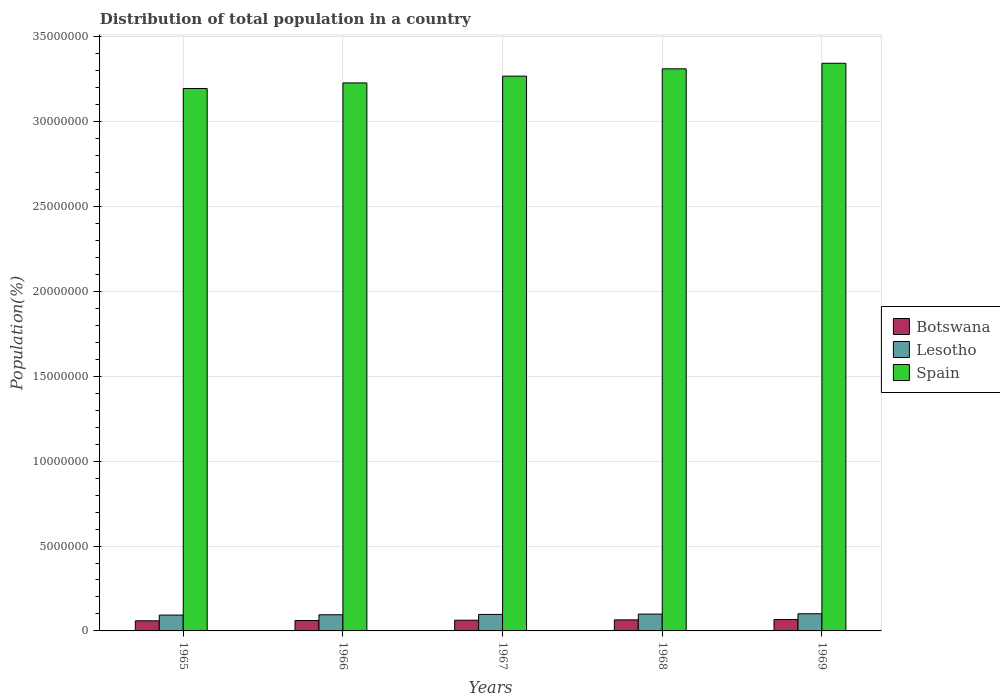Are the number of bars per tick equal to the number of legend labels?
Provide a succinct answer. Yes. How many bars are there on the 5th tick from the right?
Give a very brief answer. 3. What is the label of the 5th group of bars from the left?
Provide a succinct answer. 1969. In how many cases, is the number of bars for a given year not equal to the number of legend labels?
Ensure brevity in your answer.  0. What is the population of in Spain in 1967?
Provide a short and direct response. 3.27e+07. Across all years, what is the maximum population of in Lesotho?
Provide a succinct answer. 1.01e+06. Across all years, what is the minimum population of in Botswana?
Give a very brief answer. 5.96e+05. In which year was the population of in Lesotho maximum?
Provide a short and direct response. 1969. In which year was the population of in Spain minimum?
Provide a succinct answer. 1965. What is the total population of in Botswana in the graph?
Give a very brief answer. 3.16e+06. What is the difference between the population of in Botswana in 1967 and that in 1969?
Keep it short and to the point. -4.00e+04. What is the difference between the population of in Lesotho in 1965 and the population of in Botswana in 1968?
Provide a short and direct response. 2.83e+05. What is the average population of in Lesotho per year?
Offer a very short reply. 9.72e+05. In the year 1968, what is the difference between the population of in Spain and population of in Botswana?
Ensure brevity in your answer.  3.25e+07. What is the ratio of the population of in Lesotho in 1965 to that in 1969?
Your response must be concise. 0.92. What is the difference between the highest and the second highest population of in Botswana?
Offer a very short reply. 2.06e+04. What is the difference between the highest and the lowest population of in Spain?
Give a very brief answer. 1.49e+06. In how many years, is the population of in Botswana greater than the average population of in Botswana taken over all years?
Your response must be concise. 2. What does the 2nd bar from the left in 1966 represents?
Your answer should be very brief. Lesotho. Is it the case that in every year, the sum of the population of in Spain and population of in Botswana is greater than the population of in Lesotho?
Offer a terse response. Yes. How many years are there in the graph?
Give a very brief answer. 5. What is the difference between two consecutive major ticks on the Y-axis?
Offer a terse response. 5.00e+06. Are the values on the major ticks of Y-axis written in scientific E-notation?
Make the answer very short. No. Does the graph contain any zero values?
Make the answer very short. No. Where does the legend appear in the graph?
Offer a very short reply. Center right. What is the title of the graph?
Make the answer very short. Distribution of total population in a country. What is the label or title of the X-axis?
Ensure brevity in your answer.  Years. What is the label or title of the Y-axis?
Keep it short and to the point. Population(%). What is the Population(%) in Botswana in 1965?
Your response must be concise. 5.96e+05. What is the Population(%) in Lesotho in 1965?
Your answer should be very brief. 9.33e+05. What is the Population(%) of Spain in 1965?
Ensure brevity in your answer.  3.20e+07. What is the Population(%) in Botswana in 1966?
Ensure brevity in your answer.  6.13e+05. What is the Population(%) of Lesotho in 1966?
Your answer should be very brief. 9.52e+05. What is the Population(%) of Spain in 1966?
Offer a terse response. 3.23e+07. What is the Population(%) in Botswana in 1967?
Ensure brevity in your answer.  6.31e+05. What is the Population(%) of Lesotho in 1967?
Provide a short and direct response. 9.71e+05. What is the Population(%) in Spain in 1967?
Make the answer very short. 3.27e+07. What is the Population(%) of Botswana in 1968?
Offer a very short reply. 6.51e+05. What is the Population(%) of Lesotho in 1968?
Offer a very short reply. 9.91e+05. What is the Population(%) in Spain in 1968?
Offer a very short reply. 3.31e+07. What is the Population(%) in Botswana in 1969?
Your response must be concise. 6.71e+05. What is the Population(%) in Lesotho in 1969?
Offer a very short reply. 1.01e+06. What is the Population(%) of Spain in 1969?
Your answer should be very brief. 3.34e+07. Across all years, what is the maximum Population(%) of Botswana?
Offer a terse response. 6.71e+05. Across all years, what is the maximum Population(%) in Lesotho?
Ensure brevity in your answer.  1.01e+06. Across all years, what is the maximum Population(%) in Spain?
Offer a very short reply. 3.34e+07. Across all years, what is the minimum Population(%) in Botswana?
Ensure brevity in your answer.  5.96e+05. Across all years, what is the minimum Population(%) of Lesotho?
Offer a very short reply. 9.33e+05. Across all years, what is the minimum Population(%) of Spain?
Ensure brevity in your answer.  3.20e+07. What is the total Population(%) of Botswana in the graph?
Give a very brief answer. 3.16e+06. What is the total Population(%) in Lesotho in the graph?
Ensure brevity in your answer.  4.86e+06. What is the total Population(%) of Spain in the graph?
Your answer should be very brief. 1.63e+08. What is the difference between the Population(%) of Botswana in 1965 and that in 1966?
Give a very brief answer. -1.72e+04. What is the difference between the Population(%) in Lesotho in 1965 and that in 1966?
Ensure brevity in your answer.  -1.85e+04. What is the difference between the Population(%) of Spain in 1965 and that in 1966?
Your response must be concise. -3.29e+05. What is the difference between the Population(%) of Botswana in 1965 and that in 1967?
Keep it short and to the point. -3.55e+04. What is the difference between the Population(%) in Lesotho in 1965 and that in 1967?
Give a very brief answer. -3.77e+04. What is the difference between the Population(%) of Spain in 1965 and that in 1967?
Make the answer very short. -7.29e+05. What is the difference between the Population(%) in Botswana in 1965 and that in 1968?
Provide a short and direct response. -5.50e+04. What is the difference between the Population(%) in Lesotho in 1965 and that in 1968?
Give a very brief answer. -5.76e+04. What is the difference between the Population(%) in Spain in 1965 and that in 1968?
Offer a terse response. -1.16e+06. What is the difference between the Population(%) in Botswana in 1965 and that in 1969?
Give a very brief answer. -7.56e+04. What is the difference between the Population(%) of Lesotho in 1965 and that in 1969?
Provide a short and direct response. -7.81e+04. What is the difference between the Population(%) of Spain in 1965 and that in 1969?
Offer a terse response. -1.49e+06. What is the difference between the Population(%) in Botswana in 1966 and that in 1967?
Make the answer very short. -1.83e+04. What is the difference between the Population(%) of Lesotho in 1966 and that in 1967?
Give a very brief answer. -1.92e+04. What is the difference between the Population(%) in Spain in 1966 and that in 1967?
Your answer should be compact. -4.00e+05. What is the difference between the Population(%) in Botswana in 1966 and that in 1968?
Your response must be concise. -3.78e+04. What is the difference between the Population(%) of Lesotho in 1966 and that in 1968?
Ensure brevity in your answer.  -3.91e+04. What is the difference between the Population(%) of Spain in 1966 and that in 1968?
Provide a short and direct response. -8.30e+05. What is the difference between the Population(%) of Botswana in 1966 and that in 1969?
Make the answer very short. -5.84e+04. What is the difference between the Population(%) in Lesotho in 1966 and that in 1969?
Ensure brevity in your answer.  -5.96e+04. What is the difference between the Population(%) of Spain in 1966 and that in 1969?
Your answer should be very brief. -1.16e+06. What is the difference between the Population(%) in Botswana in 1967 and that in 1968?
Offer a terse response. -1.95e+04. What is the difference between the Population(%) in Lesotho in 1967 and that in 1968?
Ensure brevity in your answer.  -1.99e+04. What is the difference between the Population(%) in Spain in 1967 and that in 1968?
Provide a short and direct response. -4.30e+05. What is the difference between the Population(%) of Botswana in 1967 and that in 1969?
Provide a succinct answer. -4.00e+04. What is the difference between the Population(%) of Lesotho in 1967 and that in 1969?
Provide a short and direct response. -4.03e+04. What is the difference between the Population(%) of Spain in 1967 and that in 1969?
Give a very brief answer. -7.58e+05. What is the difference between the Population(%) in Botswana in 1968 and that in 1969?
Offer a very short reply. -2.06e+04. What is the difference between the Population(%) in Lesotho in 1968 and that in 1969?
Your response must be concise. -2.04e+04. What is the difference between the Population(%) of Spain in 1968 and that in 1969?
Keep it short and to the point. -3.28e+05. What is the difference between the Population(%) in Botswana in 1965 and the Population(%) in Lesotho in 1966?
Give a very brief answer. -3.56e+05. What is the difference between the Population(%) of Botswana in 1965 and the Population(%) of Spain in 1966?
Your answer should be very brief. -3.17e+07. What is the difference between the Population(%) of Lesotho in 1965 and the Population(%) of Spain in 1966?
Provide a succinct answer. -3.13e+07. What is the difference between the Population(%) of Botswana in 1965 and the Population(%) of Lesotho in 1967?
Your answer should be very brief. -3.75e+05. What is the difference between the Population(%) in Botswana in 1965 and the Population(%) in Spain in 1967?
Offer a very short reply. -3.21e+07. What is the difference between the Population(%) in Lesotho in 1965 and the Population(%) in Spain in 1967?
Your response must be concise. -3.17e+07. What is the difference between the Population(%) of Botswana in 1965 and the Population(%) of Lesotho in 1968?
Provide a succinct answer. -3.95e+05. What is the difference between the Population(%) in Botswana in 1965 and the Population(%) in Spain in 1968?
Your response must be concise. -3.25e+07. What is the difference between the Population(%) of Lesotho in 1965 and the Population(%) of Spain in 1968?
Your response must be concise. -3.22e+07. What is the difference between the Population(%) in Botswana in 1965 and the Population(%) in Lesotho in 1969?
Give a very brief answer. -4.16e+05. What is the difference between the Population(%) in Botswana in 1965 and the Population(%) in Spain in 1969?
Keep it short and to the point. -3.28e+07. What is the difference between the Population(%) of Lesotho in 1965 and the Population(%) of Spain in 1969?
Provide a short and direct response. -3.25e+07. What is the difference between the Population(%) of Botswana in 1966 and the Population(%) of Lesotho in 1967?
Offer a very short reply. -3.58e+05. What is the difference between the Population(%) of Botswana in 1966 and the Population(%) of Spain in 1967?
Keep it short and to the point. -3.21e+07. What is the difference between the Population(%) in Lesotho in 1966 and the Population(%) in Spain in 1967?
Make the answer very short. -3.17e+07. What is the difference between the Population(%) of Botswana in 1966 and the Population(%) of Lesotho in 1968?
Give a very brief answer. -3.78e+05. What is the difference between the Population(%) in Botswana in 1966 and the Population(%) in Spain in 1968?
Offer a very short reply. -3.25e+07. What is the difference between the Population(%) of Lesotho in 1966 and the Population(%) of Spain in 1968?
Your answer should be very brief. -3.22e+07. What is the difference between the Population(%) of Botswana in 1966 and the Population(%) of Lesotho in 1969?
Offer a terse response. -3.98e+05. What is the difference between the Population(%) of Botswana in 1966 and the Population(%) of Spain in 1969?
Your answer should be very brief. -3.28e+07. What is the difference between the Population(%) in Lesotho in 1966 and the Population(%) in Spain in 1969?
Give a very brief answer. -3.25e+07. What is the difference between the Population(%) of Botswana in 1967 and the Population(%) of Lesotho in 1968?
Ensure brevity in your answer.  -3.60e+05. What is the difference between the Population(%) in Botswana in 1967 and the Population(%) in Spain in 1968?
Keep it short and to the point. -3.25e+07. What is the difference between the Population(%) in Lesotho in 1967 and the Population(%) in Spain in 1968?
Your response must be concise. -3.21e+07. What is the difference between the Population(%) of Botswana in 1967 and the Population(%) of Lesotho in 1969?
Your answer should be very brief. -3.80e+05. What is the difference between the Population(%) of Botswana in 1967 and the Population(%) of Spain in 1969?
Offer a very short reply. -3.28e+07. What is the difference between the Population(%) of Lesotho in 1967 and the Population(%) of Spain in 1969?
Offer a very short reply. -3.25e+07. What is the difference between the Population(%) in Botswana in 1968 and the Population(%) in Lesotho in 1969?
Your response must be concise. -3.61e+05. What is the difference between the Population(%) of Botswana in 1968 and the Population(%) of Spain in 1969?
Offer a very short reply. -3.28e+07. What is the difference between the Population(%) of Lesotho in 1968 and the Population(%) of Spain in 1969?
Provide a short and direct response. -3.25e+07. What is the average Population(%) in Botswana per year?
Ensure brevity in your answer.  6.32e+05. What is the average Population(%) of Lesotho per year?
Offer a very short reply. 9.72e+05. What is the average Population(%) of Spain per year?
Offer a very short reply. 3.27e+07. In the year 1965, what is the difference between the Population(%) in Botswana and Population(%) in Lesotho?
Your response must be concise. -3.38e+05. In the year 1965, what is the difference between the Population(%) of Botswana and Population(%) of Spain?
Offer a terse response. -3.14e+07. In the year 1965, what is the difference between the Population(%) of Lesotho and Population(%) of Spain?
Make the answer very short. -3.10e+07. In the year 1966, what is the difference between the Population(%) of Botswana and Population(%) of Lesotho?
Provide a short and direct response. -3.39e+05. In the year 1966, what is the difference between the Population(%) in Botswana and Population(%) in Spain?
Provide a succinct answer. -3.17e+07. In the year 1966, what is the difference between the Population(%) in Lesotho and Population(%) in Spain?
Give a very brief answer. -3.13e+07. In the year 1967, what is the difference between the Population(%) of Botswana and Population(%) of Lesotho?
Give a very brief answer. -3.40e+05. In the year 1967, what is the difference between the Population(%) of Botswana and Population(%) of Spain?
Ensure brevity in your answer.  -3.21e+07. In the year 1967, what is the difference between the Population(%) of Lesotho and Population(%) of Spain?
Give a very brief answer. -3.17e+07. In the year 1968, what is the difference between the Population(%) of Botswana and Population(%) of Lesotho?
Make the answer very short. -3.40e+05. In the year 1968, what is the difference between the Population(%) of Botswana and Population(%) of Spain?
Make the answer very short. -3.25e+07. In the year 1968, what is the difference between the Population(%) in Lesotho and Population(%) in Spain?
Your response must be concise. -3.21e+07. In the year 1969, what is the difference between the Population(%) of Botswana and Population(%) of Lesotho?
Offer a very short reply. -3.40e+05. In the year 1969, what is the difference between the Population(%) of Botswana and Population(%) of Spain?
Your answer should be very brief. -3.28e+07. In the year 1969, what is the difference between the Population(%) in Lesotho and Population(%) in Spain?
Provide a short and direct response. -3.24e+07. What is the ratio of the Population(%) of Botswana in 1965 to that in 1966?
Provide a short and direct response. 0.97. What is the ratio of the Population(%) in Lesotho in 1965 to that in 1966?
Make the answer very short. 0.98. What is the ratio of the Population(%) of Botswana in 1965 to that in 1967?
Your answer should be compact. 0.94. What is the ratio of the Population(%) in Lesotho in 1965 to that in 1967?
Give a very brief answer. 0.96. What is the ratio of the Population(%) of Spain in 1965 to that in 1967?
Offer a terse response. 0.98. What is the ratio of the Population(%) in Botswana in 1965 to that in 1968?
Your answer should be compact. 0.92. What is the ratio of the Population(%) in Lesotho in 1965 to that in 1968?
Keep it short and to the point. 0.94. What is the ratio of the Population(%) in Botswana in 1965 to that in 1969?
Your response must be concise. 0.89. What is the ratio of the Population(%) in Lesotho in 1965 to that in 1969?
Your response must be concise. 0.92. What is the ratio of the Population(%) of Spain in 1965 to that in 1969?
Your answer should be very brief. 0.96. What is the ratio of the Population(%) in Botswana in 1966 to that in 1967?
Offer a terse response. 0.97. What is the ratio of the Population(%) of Lesotho in 1966 to that in 1967?
Offer a terse response. 0.98. What is the ratio of the Population(%) in Botswana in 1966 to that in 1968?
Your answer should be very brief. 0.94. What is the ratio of the Population(%) of Lesotho in 1966 to that in 1968?
Provide a succinct answer. 0.96. What is the ratio of the Population(%) in Spain in 1966 to that in 1968?
Make the answer very short. 0.97. What is the ratio of the Population(%) of Botswana in 1966 to that in 1969?
Provide a short and direct response. 0.91. What is the ratio of the Population(%) of Lesotho in 1966 to that in 1969?
Give a very brief answer. 0.94. What is the ratio of the Population(%) in Spain in 1966 to that in 1969?
Keep it short and to the point. 0.97. What is the ratio of the Population(%) of Botswana in 1967 to that in 1968?
Provide a succinct answer. 0.97. What is the ratio of the Population(%) of Lesotho in 1967 to that in 1968?
Ensure brevity in your answer.  0.98. What is the ratio of the Population(%) in Botswana in 1967 to that in 1969?
Offer a terse response. 0.94. What is the ratio of the Population(%) of Lesotho in 1967 to that in 1969?
Make the answer very short. 0.96. What is the ratio of the Population(%) of Spain in 1967 to that in 1969?
Provide a short and direct response. 0.98. What is the ratio of the Population(%) in Botswana in 1968 to that in 1969?
Your response must be concise. 0.97. What is the ratio of the Population(%) of Lesotho in 1968 to that in 1969?
Give a very brief answer. 0.98. What is the ratio of the Population(%) in Spain in 1968 to that in 1969?
Your response must be concise. 0.99. What is the difference between the highest and the second highest Population(%) of Botswana?
Ensure brevity in your answer.  2.06e+04. What is the difference between the highest and the second highest Population(%) in Lesotho?
Your answer should be compact. 2.04e+04. What is the difference between the highest and the second highest Population(%) of Spain?
Give a very brief answer. 3.28e+05. What is the difference between the highest and the lowest Population(%) of Botswana?
Your answer should be compact. 7.56e+04. What is the difference between the highest and the lowest Population(%) in Lesotho?
Your answer should be compact. 7.81e+04. What is the difference between the highest and the lowest Population(%) in Spain?
Provide a short and direct response. 1.49e+06. 